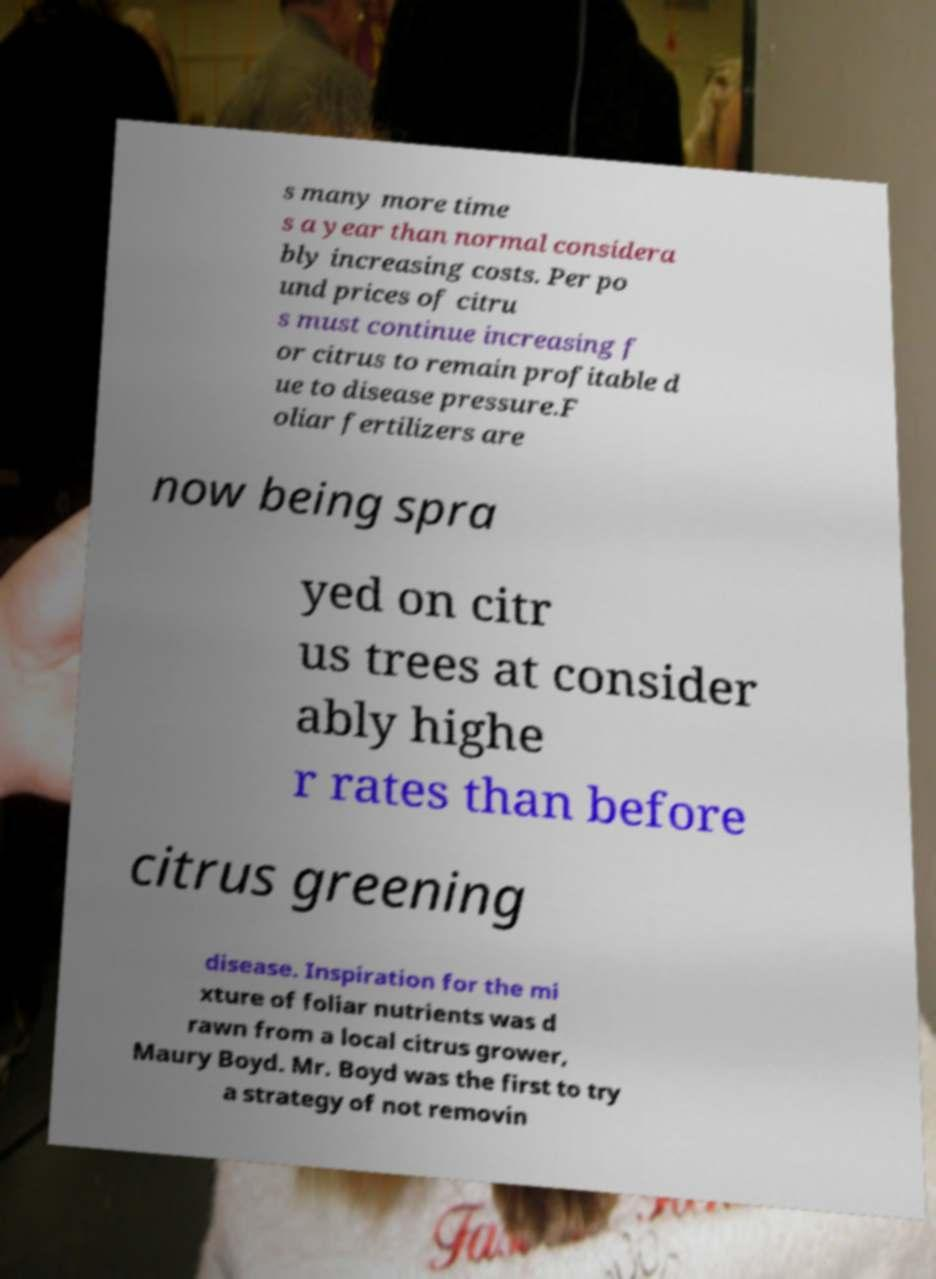Could you extract and type out the text from this image? s many more time s a year than normal considera bly increasing costs. Per po und prices of citru s must continue increasing f or citrus to remain profitable d ue to disease pressure.F oliar fertilizers are now being spra yed on citr us trees at consider ably highe r rates than before citrus greening disease. Inspiration for the mi xture of foliar nutrients was d rawn from a local citrus grower, Maury Boyd. Mr. Boyd was the first to try a strategy of not removin 